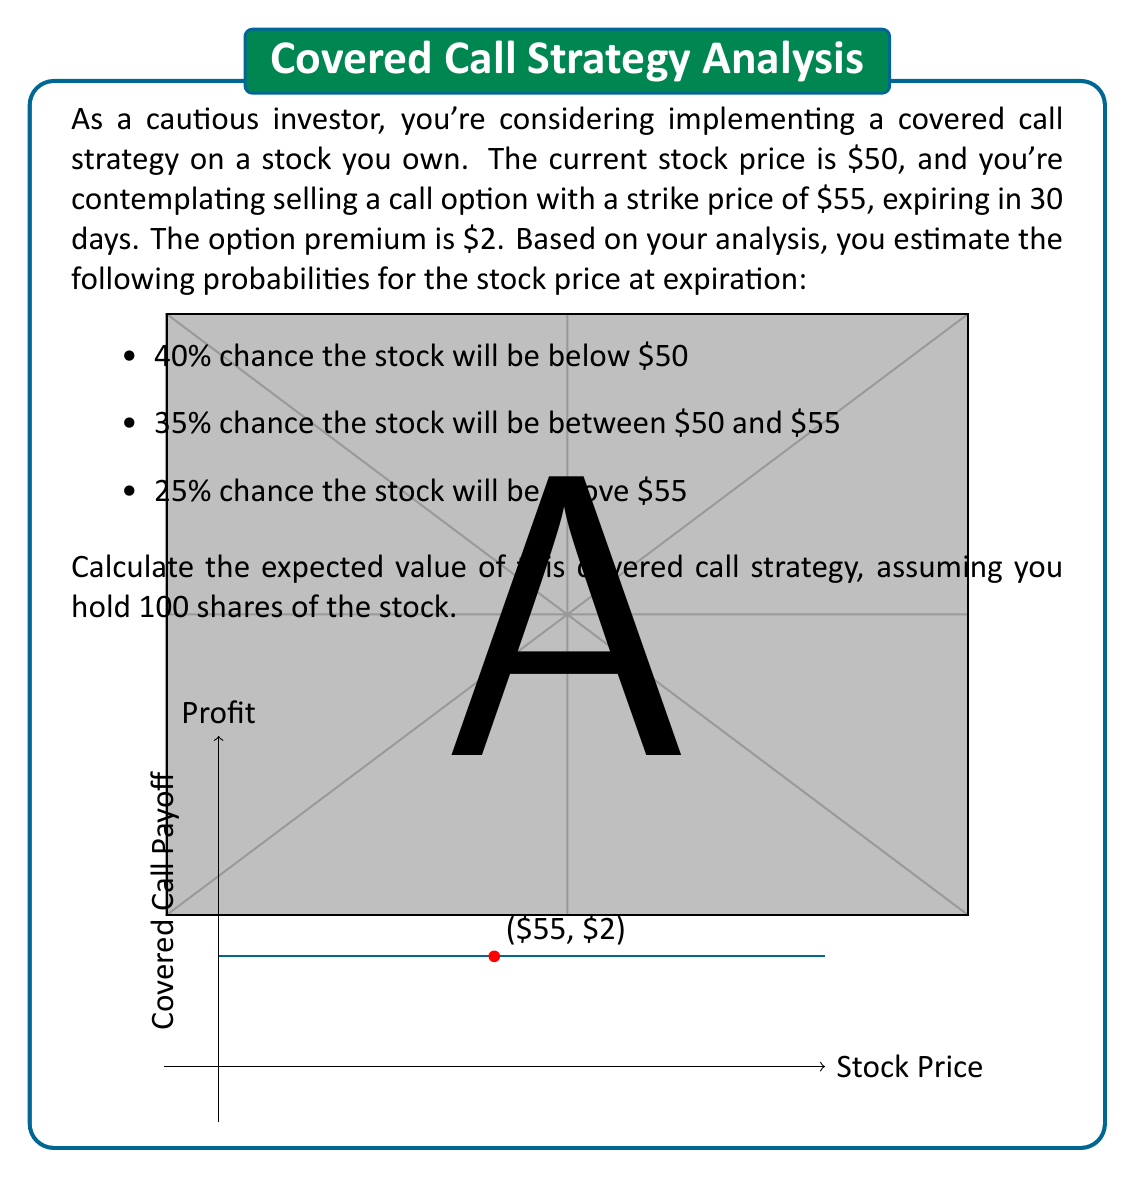Solve this math problem. Let's break this down step-by-step:

1) First, let's calculate the potential outcomes for each scenario:

   a) Stock below $50:
      Profit = Premium received = $2 per share
   
   b) Stock between $50 and $55:
      Profit = Premium received = $2 per share
   
   c) Stock above $55:
      Profit = Premium + (Strike Price - Current Price)
             = $2 + ($55 - $50) = $7 per share

2) Now, let's calculate the expected value for each scenario:

   a) E(Below $50) = $2 × 0.40 = $0.80
   
   b) E(Between $50 and $55) = $2 × 0.35 = $0.70
   
   c) E(Above $55) = $7 × 0.25 = $1.75

3) The total expected value is the sum of these:

   E(Total) = $0.80 + $0.70 + $1.75 = $3.25 per share

4) Since we're dealing with 100 shares:

   Total Expected Value = $3.25 × 100 = $325

Therefore, the expected value of this covered call strategy for 100 shares is $325.
Answer: $325 